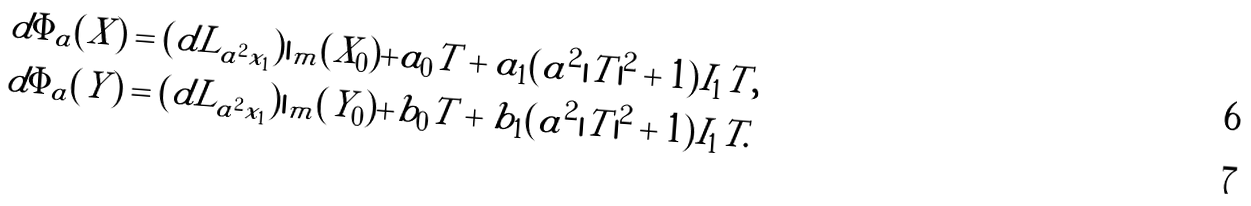Convert formula to latex. <formula><loc_0><loc_0><loc_500><loc_500>d \Phi _ { a } ( X ) & = ( d L _ { a ^ { 2 } { x _ { 1 } } } ) | _ { m } ( X _ { 0 } ) + a _ { 0 } T + a _ { 1 } ( a ^ { 2 } | T | ^ { 2 } + 1 ) I _ { 1 } T , \\ d \Phi _ { a } ( Y ) & = ( d L _ { a ^ { 2 } { x _ { 1 } } } ) | _ { m } ( Y _ { 0 } ) + b _ { 0 } T + b _ { 1 } ( a ^ { 2 } | T | ^ { 2 } + 1 ) I _ { 1 } T .</formula> 